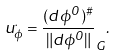<formula> <loc_0><loc_0><loc_500><loc_500>u ^ { . } _ { \phi } = \frac { ( d \phi ^ { 0 } ) ^ { \# } } { \| d \phi ^ { 0 } \| } _ { G } .</formula> 